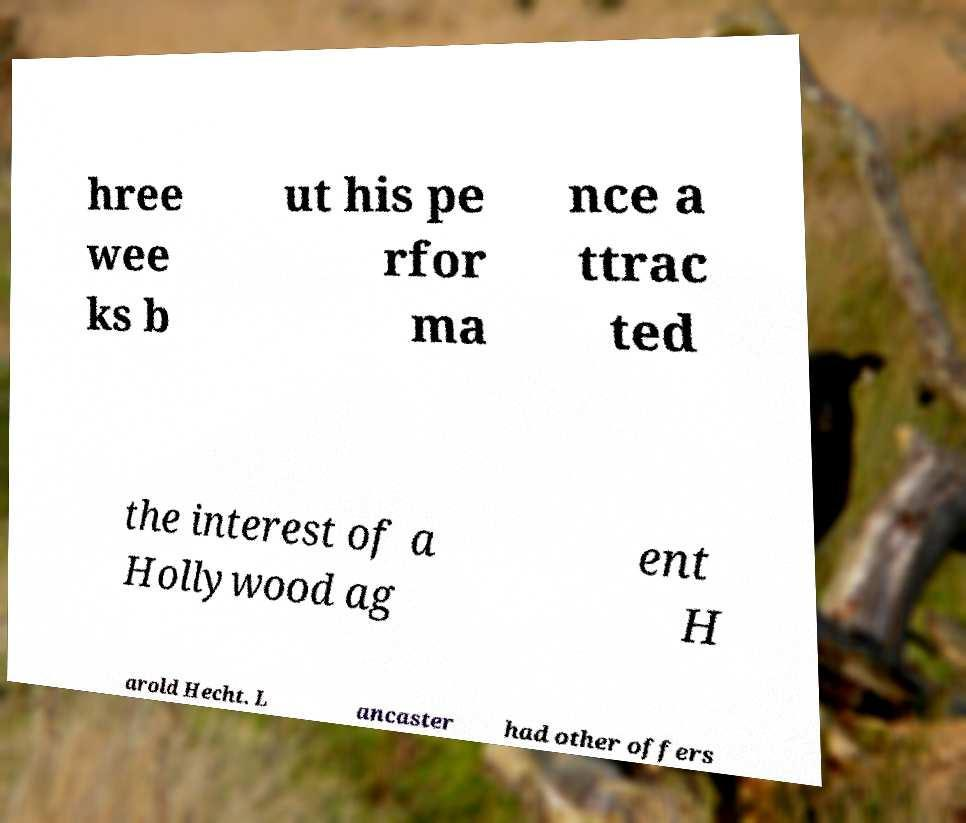There's text embedded in this image that I need extracted. Can you transcribe it verbatim? hree wee ks b ut his pe rfor ma nce a ttrac ted the interest of a Hollywood ag ent H arold Hecht. L ancaster had other offers 